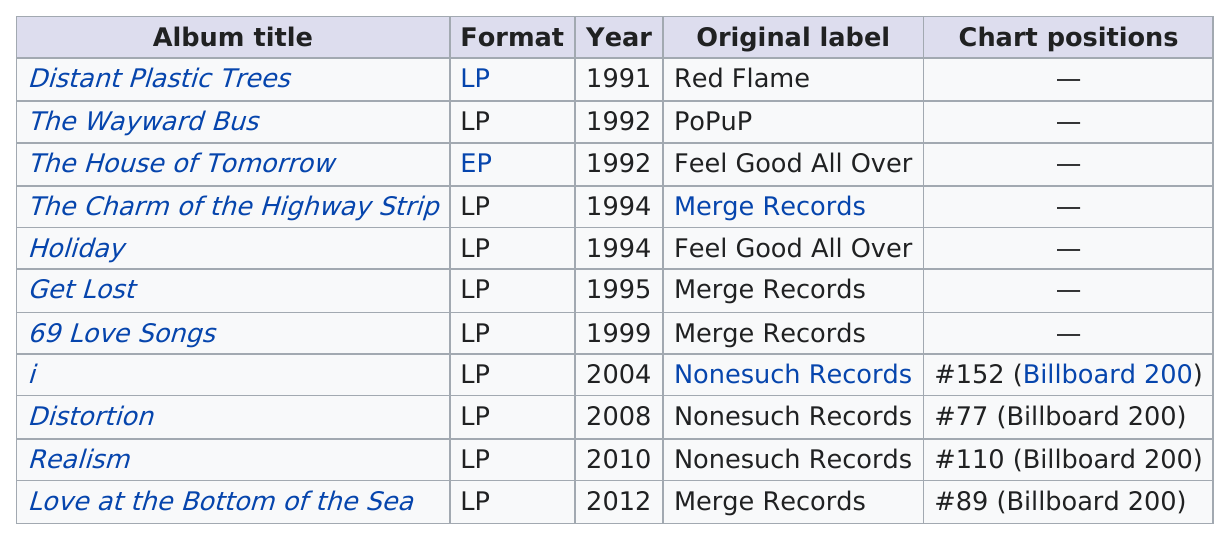Identify some key points in this picture. Four albums have appeared in at least the Billboard top 200. The highest position of distortion was 76, and how many albums did it fall below at that point? The album title that came next after "Get Lost" was "69 Love Songs. Merge records released the next album of How many years after 1999 did they release it? 5 years. Which album reached the Billboard 200 chart despite being the least acclaimed? 